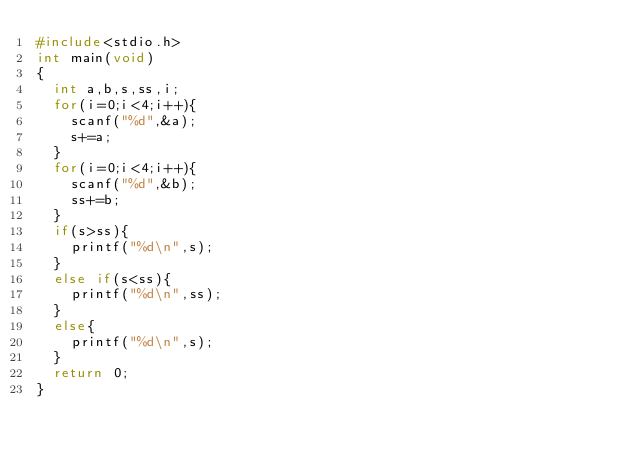<code> <loc_0><loc_0><loc_500><loc_500><_C++_>#include<stdio.h>
int main(void)
{
	int a,b,s,ss,i;
	for(i=0;i<4;i++){
		scanf("%d",&a);
		s+=a;
	}
	for(i=0;i<4;i++){
		scanf("%d",&b);
		ss+=b;
	}
	if(s>ss){
		printf("%d\n",s);
	}
	else if(s<ss){
		printf("%d\n",ss);
	}
	else{
		printf("%d\n",s);
	}
	return 0;
}</code> 